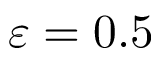Convert formula to latex. <formula><loc_0><loc_0><loc_500><loc_500>\varepsilon = 0 . 5</formula> 